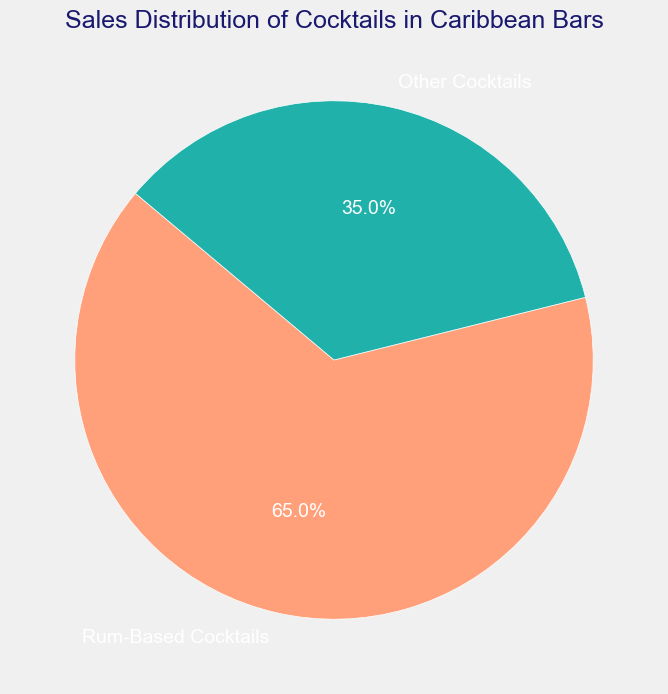What percentage of cocktails sold in Caribbean bars are rum-based? The pie chart shows that rum-based cocktails makeup 65% of the sales distribution.
Answer: 65% How does the sales distribution of rum-based cocktails compare to other cocktails in Caribbean bars? According to the pie chart, rum-based cocktails account for 65% of the sales, while other cocktails account for 35% of the sales. The rum-based cocktails dominate the sales distribution.
Answer: Rum-based cocktails have a higher percentage What is the ratio of sales for rum-based cocktails to other cocktails in Caribbean bars? To find the ratio, you divide the percentage of rum-based cocktails by the percentage of other cocktails. Hence, it’s 65/35. Simplifying this gives approximately 1.86.
Answer: 1.86:1 Which category has a greater share in the sales distribution, and by what percentage difference? The pie chart shows that rum-based cocktails have a greater share in the sales distribution. The percentage difference can be calculated as \(65 - 35\), which equals 30%.
Answer: Rum-based cocktails, 30% What is the total percentage of sales distribution represented in the pie chart? The pie chart shows two categories, rum-based and other cocktails. Adding their percentages gives \(65 + 35\), which equals 100%.
Answer: 100% What slice color corresponds to rum-based cocktails in the pie chart? The pie chart uses distinct colors for the slices. The rum-based cocktails slice is represented by a salmon color.
Answer: Salmon If the sales of other cocktails increased by 10%, what would be the new percentage of other cocktails? Initially, the other cocktails make up 35% of the sales. Increasing this by 10% means adding 10% of 35, which is 3.5. So, \(35 + 3.5 = 38.5%\) will be the new percentage.
Answer: 38.5% Is the sales distribution of rum-based cocktails more than twice that of other cocktails? By comparing 65% for rum-based cocktails to 35% for other cocktails, twice of 35% is 70%. Since 65% < 70%, the rum-based cocktails are not more than twice that of other cocktails.
Answer: No What is the combined sales percentage of both rum-based and other cocktails? The pie chart indicates the percentages for both categories. Summing these, \(65 + 35\) gives the combined sales percentage of 100%.
Answer: 100% Considering the visual properties of the pie chart, what text color is used for the labels? The text labels on the pie chart are shown in white. This makes them contrast well against the colored slices of the pie chart.
Answer: White 